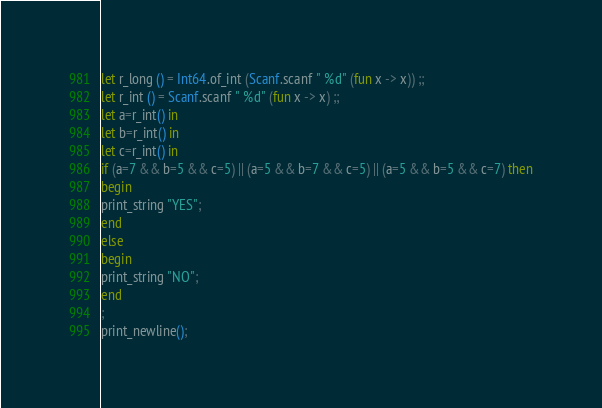<code> <loc_0><loc_0><loc_500><loc_500><_OCaml_>let r_long () = Int64.of_int (Scanf.scanf " %d" (fun x -> x)) ;;
let r_int () = Scanf.scanf " %d" (fun x -> x) ;;
let a=r_int() in
let b=r_int() in
let c=r_int() in
if (a=7 && b=5 && c=5) || (a=5 && b=7 && c=5) || (a=5 && b=5 && c=7) then
begin
print_string "YES";
end
else
begin
print_string "NO";
end
;
print_newline();
</code> 